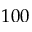Convert formula to latex. <formula><loc_0><loc_0><loc_500><loc_500>1 0 0</formula> 